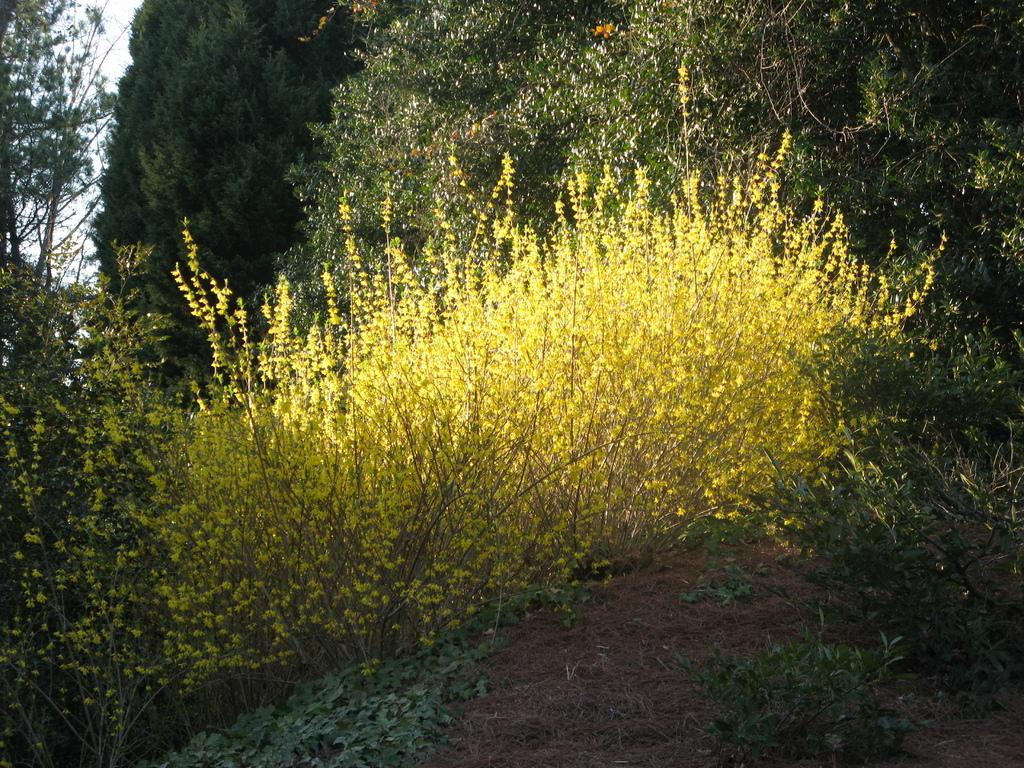What type of vegetation can be seen in the image? There are many trees and plants in the image. Can you describe the ground in the image? Mud is visible in the image. Reasoning: Let's think step by identifying the main subjects in the image, which are the trees and plants. Then, we focus on the ground and describe its appearance, which is mud. Each question is designed to elicit a specific detail about the image that is known from the provided facts. Absurd Question/Answer: What type of roof can be seen on the throne in the image? There is no throne or roof present in the image; it features trees, plants, and mud. What type of oatmeal is being served on the throne in the image? There is no throne or oatmeal present in the image; it features trees, plants, and mud. 